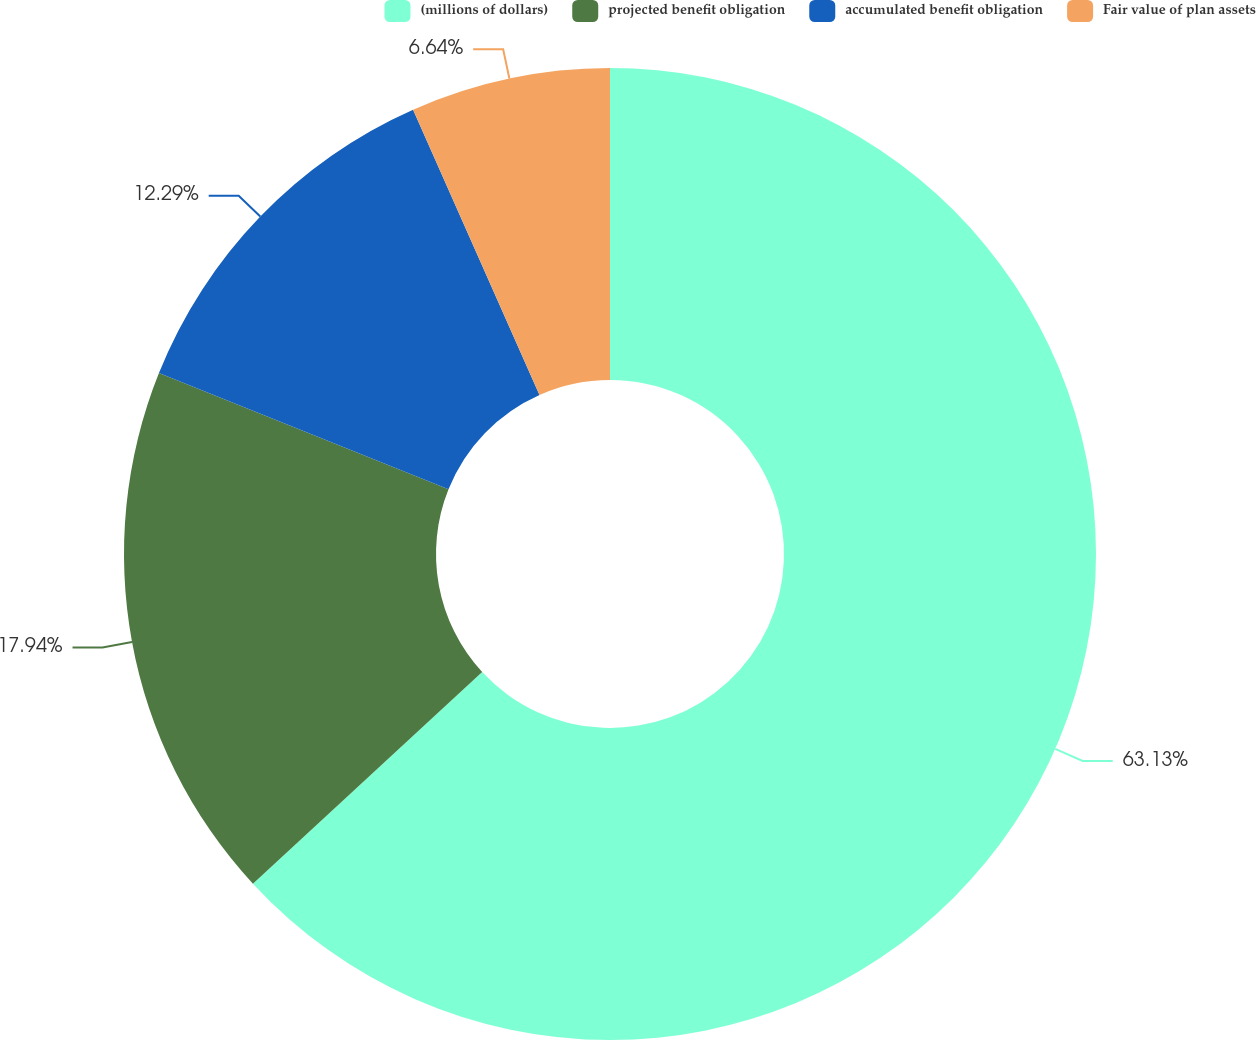Convert chart. <chart><loc_0><loc_0><loc_500><loc_500><pie_chart><fcel>(millions of dollars)<fcel>projected benefit obligation<fcel>accumulated benefit obligation<fcel>Fair value of plan assets<nl><fcel>63.14%<fcel>17.94%<fcel>12.29%<fcel>6.64%<nl></chart> 